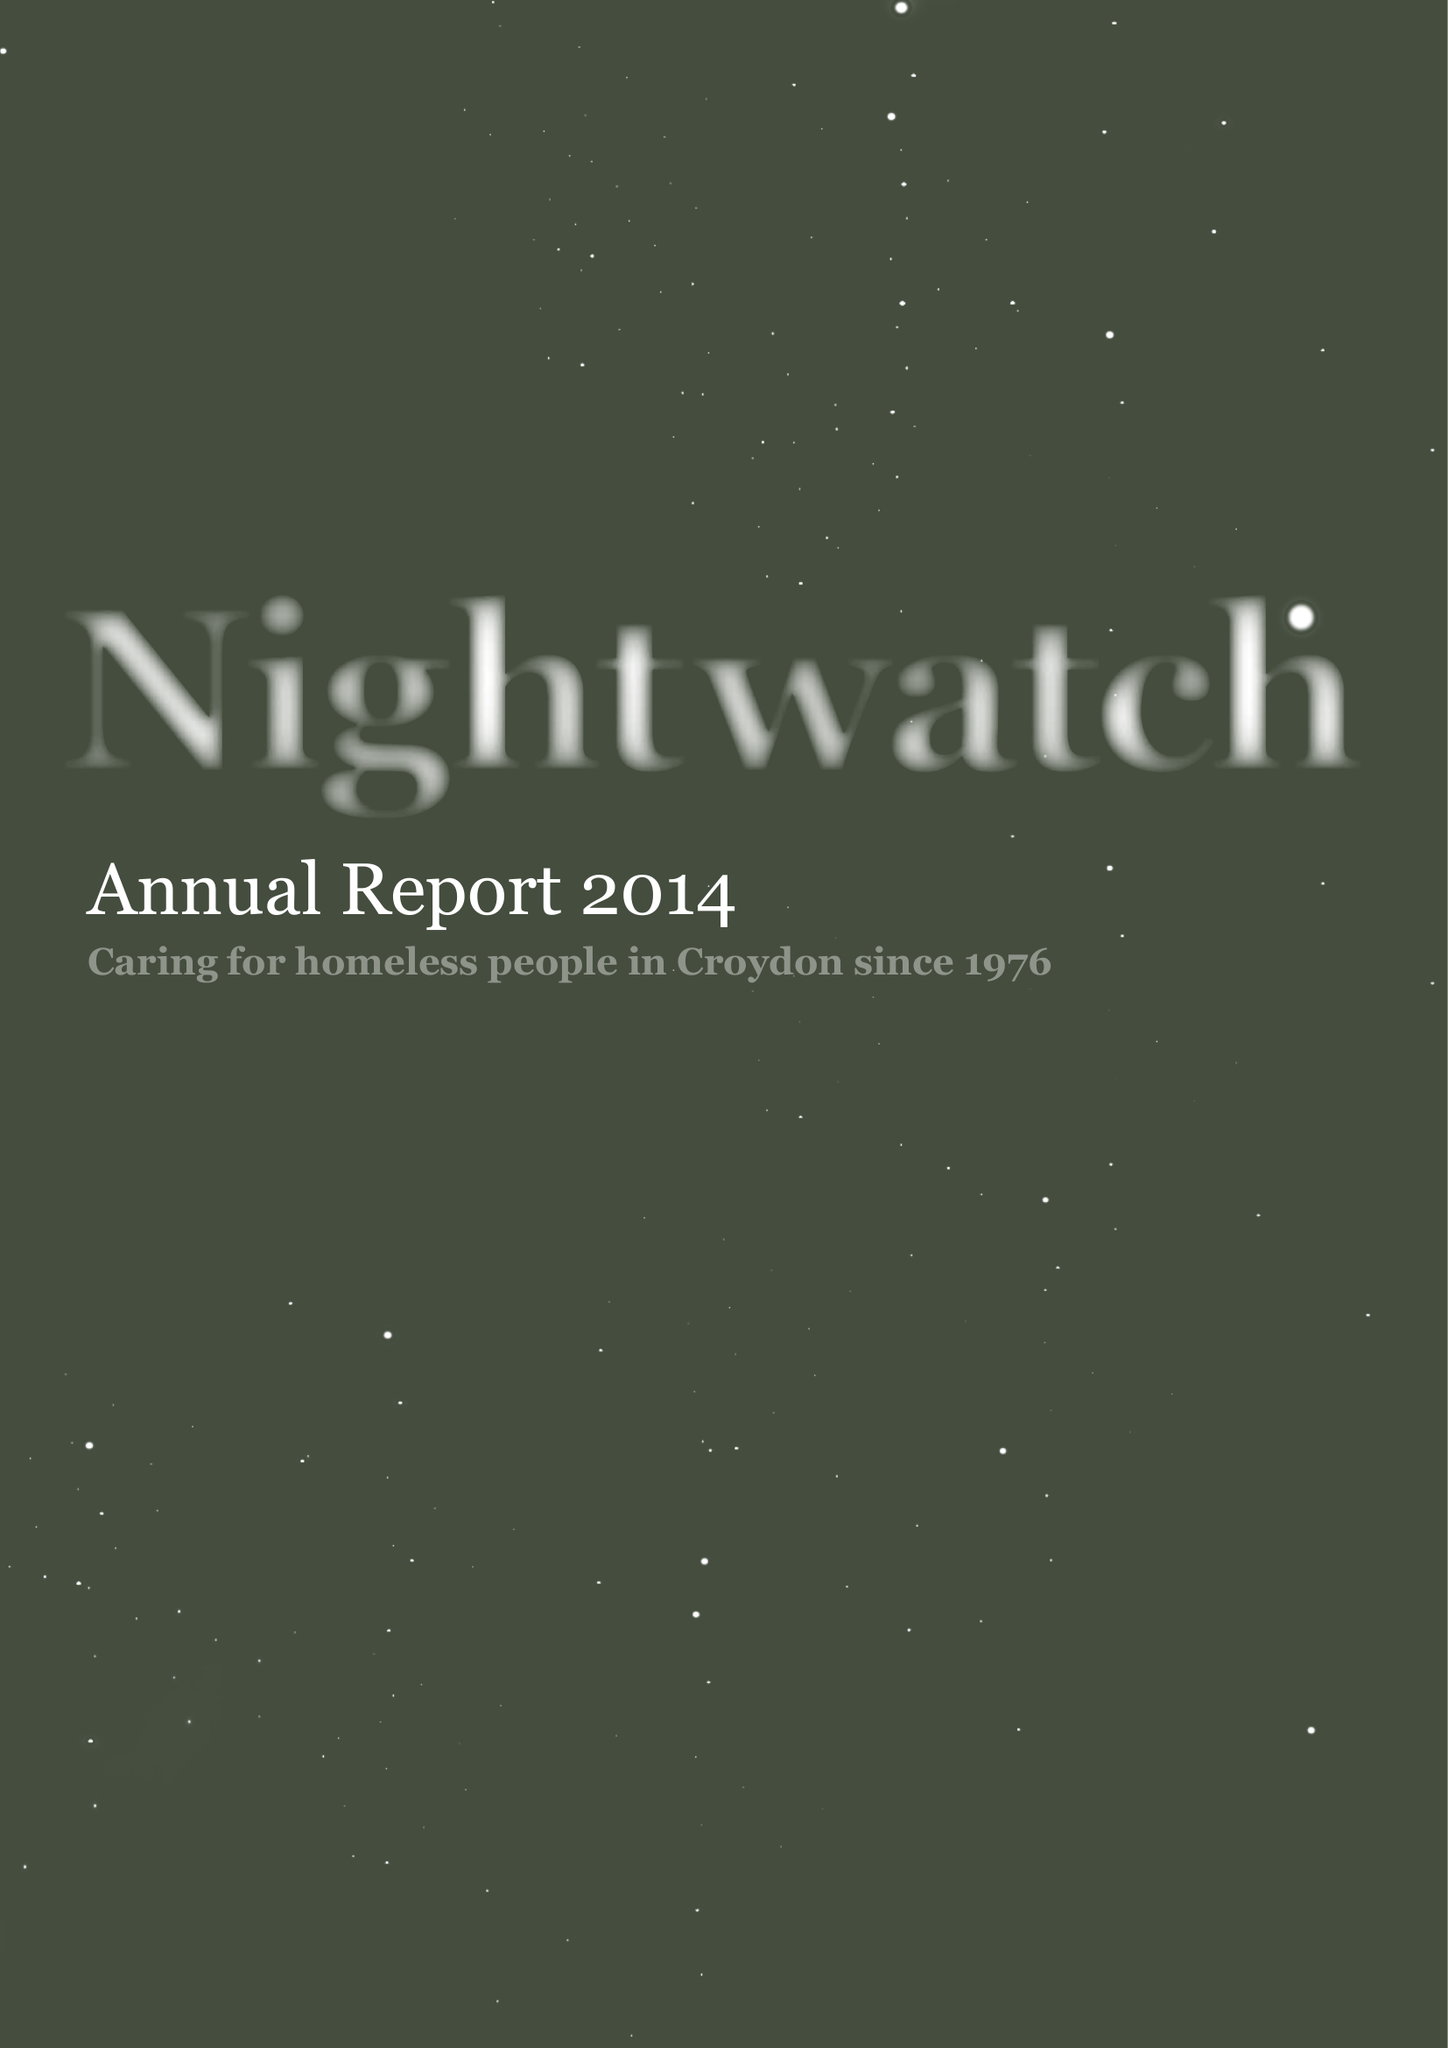What is the value for the report_date?
Answer the question using a single word or phrase. 2013-12-31 